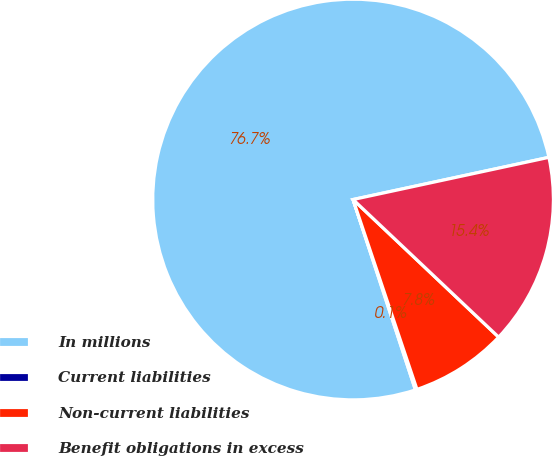Convert chart. <chart><loc_0><loc_0><loc_500><loc_500><pie_chart><fcel>In millions<fcel>Current liabilities<fcel>Non-current liabilities<fcel>Benefit obligations in excess<nl><fcel>76.66%<fcel>0.13%<fcel>7.78%<fcel>15.43%<nl></chart> 